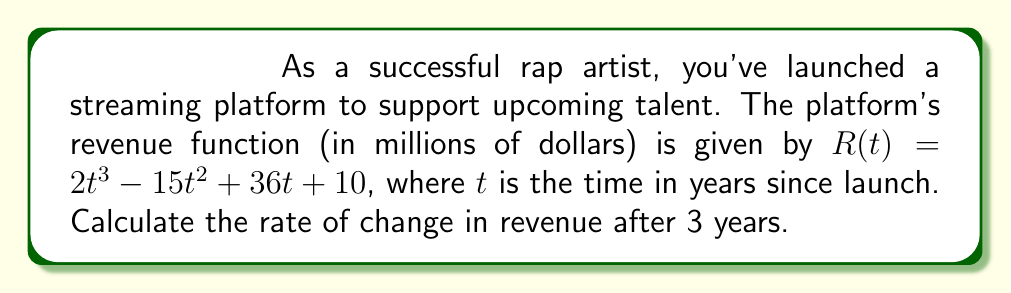Solve this math problem. To find the rate of change in revenue after 3 years, we need to calculate the derivative of the revenue function $R(t)$ and evaluate it at $t = 3$. Let's follow these steps:

1) The revenue function is:
   $R(t) = 2t^3 - 15t^2 + 36t + 10$

2) To find the derivative, we apply the power rule and constant rule:
   $R'(t) = 6t^2 - 30t + 36$

3) This derivative $R'(t)$ represents the rate of change of revenue with respect to time.

4) To find the rate of change after 3 years, we substitute $t = 3$ into $R'(t)$:
   $R'(3) = 6(3)^2 - 30(3) + 36$

5) Simplify:
   $R'(3) = 6(9) - 90 + 36$
   $R'(3) = 54 - 90 + 36$
   $R'(3) = 0$

The rate of change after 3 years is 0 million dollars per year.
Answer: $0$ million dollars per year 